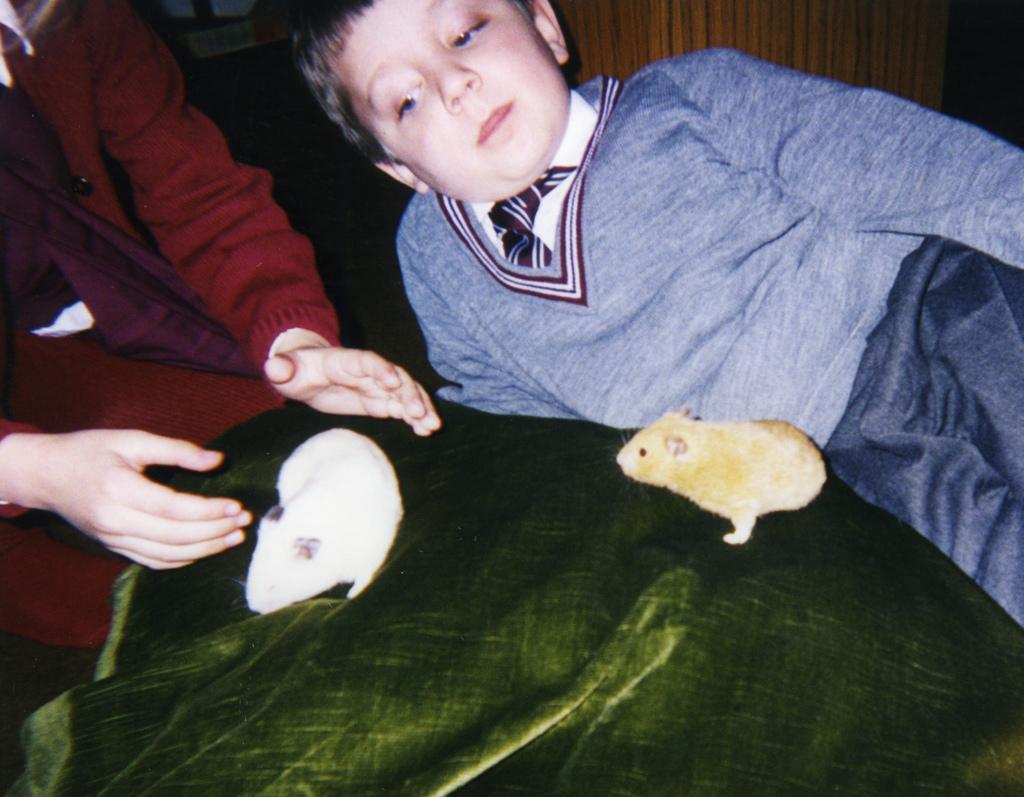Describe this image in one or two sentences. In this image, we can see a kid and at the left side there is a person sitting, we can see two small animals. 